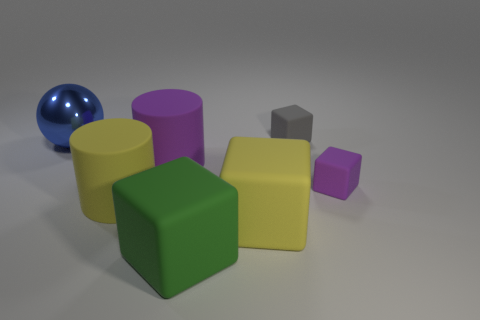Do the big green matte object and the purple matte thing that is to the right of the green rubber cube have the same shape?
Provide a short and direct response. Yes. The other small thing that is the same material as the gray thing is what color?
Provide a succinct answer. Purple. What color is the big metallic ball?
Give a very brief answer. Blue. Are the gray object and the purple thing that is behind the tiny purple thing made of the same material?
Your answer should be very brief. Yes. How many things are left of the big purple matte thing and on the right side of the blue thing?
Give a very brief answer. 1. What shape is the purple object that is the same size as the yellow cube?
Your response must be concise. Cylinder. There is a rubber cylinder behind the small thing in front of the small gray object; are there any large green rubber blocks that are in front of it?
Keep it short and to the point. Yes. What number of matte blocks have the same color as the metallic object?
Provide a succinct answer. 0. What size is the rubber block that is behind the small block in front of the blue shiny sphere?
Keep it short and to the point. Small. What number of things are things in front of the shiny ball or yellow rubber things?
Your answer should be very brief. 5. 